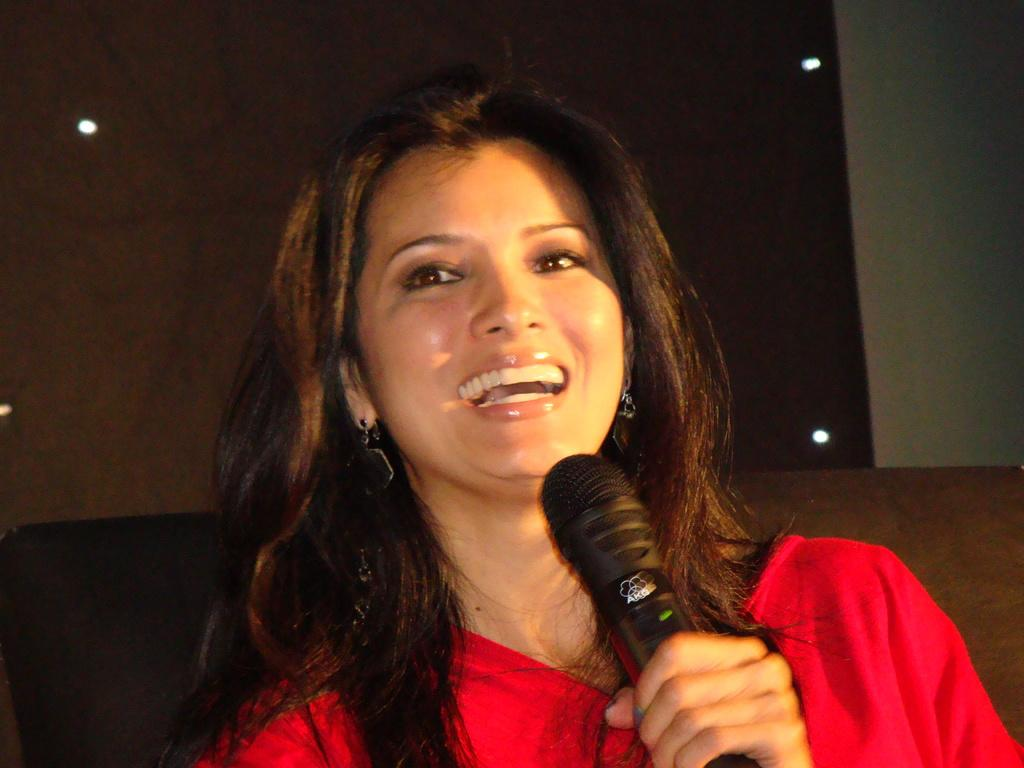Who is the main subject in the image? There is a woman in the image. What is the woman wearing? The woman is wearing a red costume. What object is the woman holding? The woman is holding a microphone. What type of feather can be seen on the woman's costume in the image? There is no feather visible on the woman's costume in the image. Can you tell me how many branches are present in the image? There are no branches present in the image; it features a woman wearing a red costume and holding a microphone. 